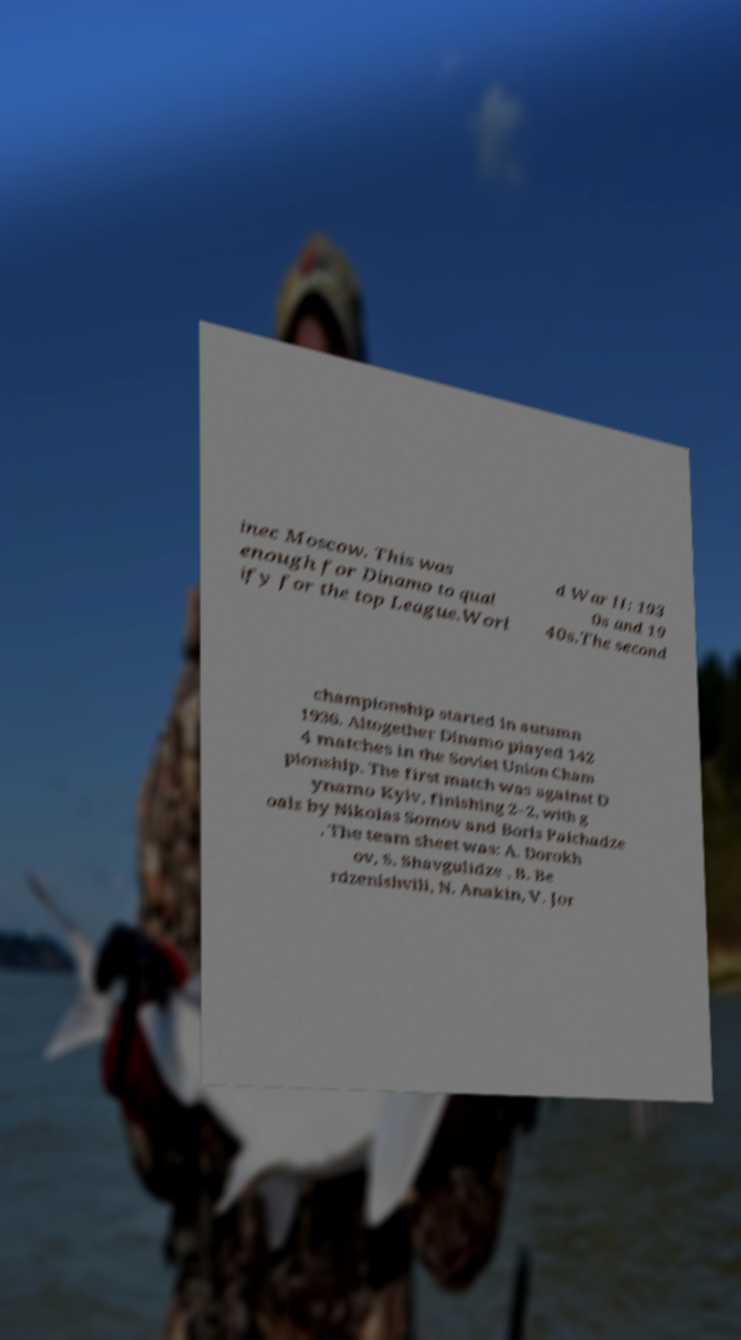What messages or text are displayed in this image? I need them in a readable, typed format. inec Moscow. This was enough for Dinamo to qual ify for the top League.Worl d War II: 193 0s and 19 40s.The second championship started in autumn 1936. Altogether Dinamo played 142 4 matches in the Soviet Union Cham pionship. The first match was against D ynamo Kyiv, finishing 2–2, with g oals by Nikolas Somov and Boris Paichadze . The team sheet was: A. Dorokh ov, S. Shavgulidze , B. Be rdzenishvili, N. Anakin, V. Jor 